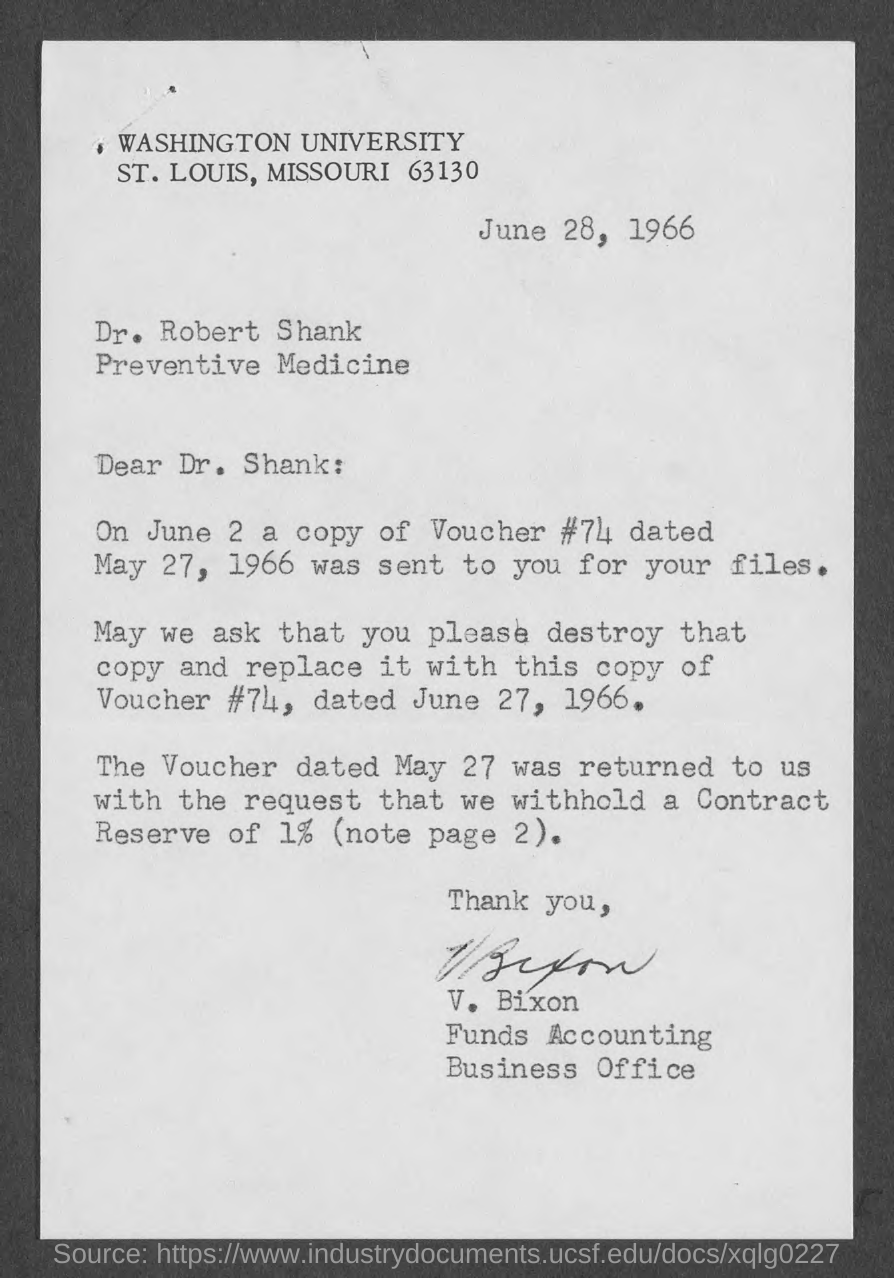Point out several critical features in this image. The date mentioned at the top of the document is June 28, 1966. The memorandum is addressed to Dr. Shank. The letter was written by V. Bixon. 